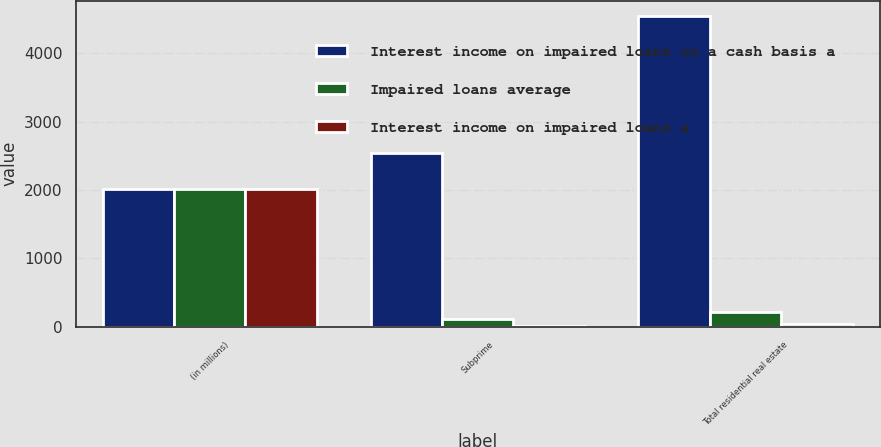<chart> <loc_0><loc_0><loc_500><loc_500><stacked_bar_chart><ecel><fcel>(in millions)<fcel>Subprime<fcel>Total residential real estate<nl><fcel>Interest income on impaired loans on a cash basis a<fcel>2010<fcel>2539<fcel>4542<nl><fcel>Impaired loans average<fcel>2010<fcel>121<fcel>216<nl><fcel>Interest income on impaired loans a<fcel>2010<fcel>19<fcel>35<nl></chart> 